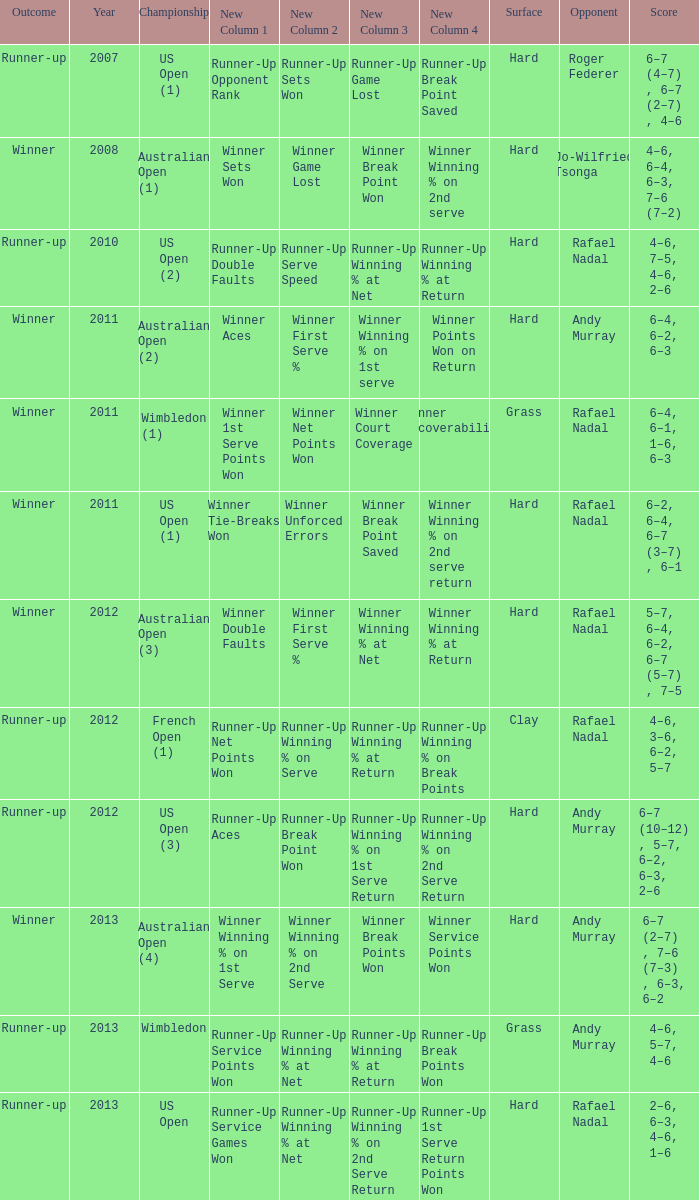Would you mind parsing the complete table? {'header': ['Outcome', 'Year', 'Championship', 'New Column 1', 'New Column 2', 'New Column 3', 'New Column 4', 'Surface', 'Opponent', 'Score'], 'rows': [['Runner-up', '2007', 'US Open (1)', 'Runner-Up Opponent Rank', 'Runner-Up Sets Won', 'Runner-Up Game Lost', 'Runner-Up Break Point Saved', 'Hard', 'Roger Federer', '6–7 (4–7) , 6–7 (2–7) , 4–6'], ['Winner', '2008', 'Australian Open (1)', 'Winner Sets Won', 'Winner Game Lost', 'Winner Break Point Won', 'Winner Winning % on 2nd serve', 'Hard', 'Jo-Wilfried Tsonga', '4–6, 6–4, 6–3, 7–6 (7–2)'], ['Runner-up', '2010', 'US Open (2)', 'Runner-Up Double Faults', 'Runner-Up Serve Speed', 'Runner-Up Winning % at Net', 'Runner-Up Winning % at Return', 'Hard', 'Rafael Nadal', '4–6, 7–5, 4–6, 2–6'], ['Winner', '2011', 'Australian Open (2)', 'Winner Aces', 'Winner First Serve %', 'Winner Winning % on 1st serve', 'Winner Points Won on Return', 'Hard', 'Andy Murray', '6–4, 6–2, 6–3'], ['Winner', '2011', 'Wimbledon (1)', 'Winner 1st Serve Points Won', 'Winner Net Points Won', 'Winner Court Coverage', 'Winner Recoverability', 'Grass', 'Rafael Nadal', '6–4, 6–1, 1–6, 6–3'], ['Winner', '2011', 'US Open (1)', 'Winner Tie-Breaks Won', 'Winner Unforced Errors', 'Winner Break Point Saved', 'Winner Winning % on 2nd serve return', 'Hard', 'Rafael Nadal', '6–2, 6–4, 6–7 (3–7) , 6–1'], ['Winner', '2012', 'Australian Open (3)', 'Winner Double Faults', 'Winner First Serve %', 'Winner Winning % at Net', 'Winner Winning % at Return', 'Hard', 'Rafael Nadal', '5–7, 6–4, 6–2, 6–7 (5–7) , 7–5'], ['Runner-up', '2012', 'French Open (1)', 'Runner-Up Net Points Won', 'Runner-Up Winning % on Serve', 'Runner-Up Winning % at Return', 'Runner-Up Winning % on Break Points', 'Clay', 'Rafael Nadal', '4–6, 3–6, 6–2, 5–7'], ['Runner-up', '2012', 'US Open (3)', 'Runner-Up Aces', 'Runner-Up Break Point Won', 'Runner-Up Winning % on 1st Serve Return', 'Runner-Up Winning % on 2nd Serve Return', 'Hard', 'Andy Murray', '6–7 (10–12) , 5–7, 6–2, 6–3, 2–6'], ['Winner', '2013', 'Australian Open (4)', 'Winner Winning % on 1st Serve', 'Winner Winning % on 2nd Serve', 'Winner Break Points Won', 'Winner Service Points Won', 'Hard', 'Andy Murray', '6–7 (2–7) , 7–6 (7–3) , 6–3, 6–2'], ['Runner-up', '2013', 'Wimbledon', 'Runner-Up Service Points Won', 'Runner-Up Winning % at Net', 'Runner-Up Winning % at Return', 'Runner-Up Break Points Won', 'Grass', 'Andy Murray', '4–6, 5–7, 4–6'], ['Runner-up', '2013', 'US Open', 'Runner-Up Service Games Won', 'Runner-Up Winning % at Net', 'Runner-Up Winning % on 2nd Serve Return', 'Runner-Up 1st Serve Return Points Won', 'Hard', 'Rafael Nadal', '2–6, 6–3, 4–6, 1–6']]} What is the outcome of the match with Roger Federer as the opponent? Runner-up. 